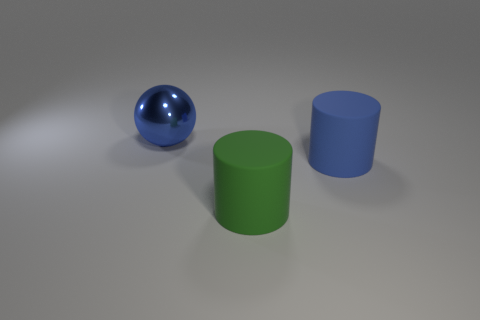There is a big object in front of the blue cylinder; is its color the same as the large rubber cylinder that is behind the big green rubber thing?
Your answer should be very brief. No. What shape is the large object that is behind the big green cylinder and in front of the big metallic object?
Make the answer very short. Cylinder. What is the color of the metal object that is the same size as the blue cylinder?
Provide a short and direct response. Blue. Is there a large cylinder that has the same color as the big metallic object?
Your response must be concise. Yes. Do the blue thing that is to the right of the green object and the matte object on the left side of the big blue matte cylinder have the same size?
Your answer should be compact. Yes. There is a object that is both behind the green rubber thing and left of the blue rubber cylinder; what is its material?
Your answer should be compact. Metal. What number of other things are the same size as the green thing?
Provide a short and direct response. 2. There is a blue thing that is right of the blue ball; what is it made of?
Keep it short and to the point. Rubber. Does the large blue matte thing have the same shape as the shiny thing?
Provide a short and direct response. No. How many other objects are the same shape as the green object?
Your answer should be very brief. 1. 